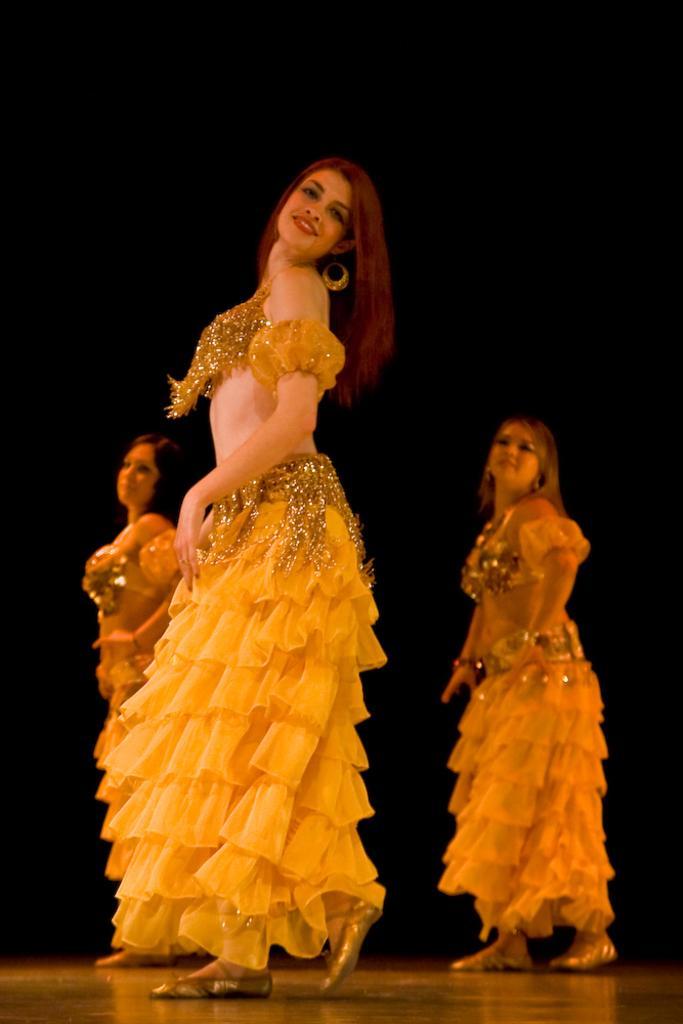Can you describe this image briefly? In this image we can see three persons dancing on the floor and the background it is dark. 